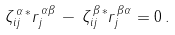<formula> <loc_0><loc_0><loc_500><loc_500>\zeta ^ { \, \alpha \, * } _ { i j } r ^ { \, \alpha \beta } _ { j } \, - \, \zeta ^ { \, \beta \, * } _ { i j } r ^ { \, \beta \alpha } _ { j } = 0 \, .</formula> 